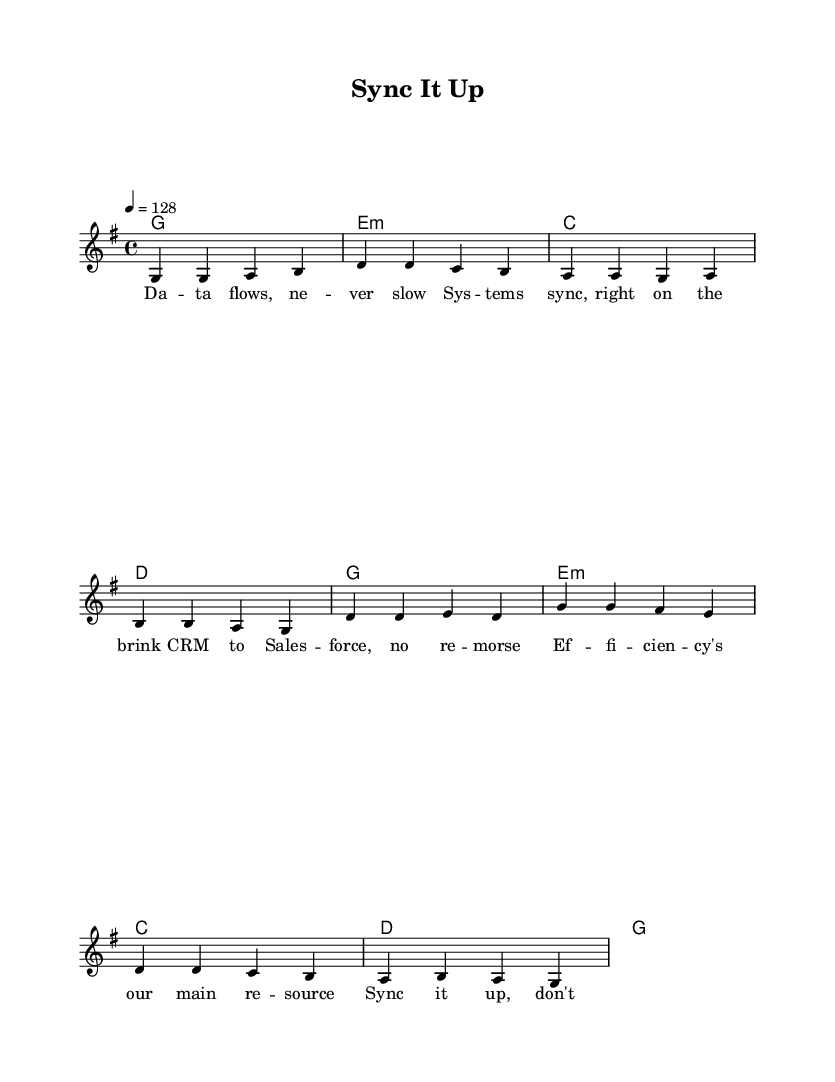What is the key signature of this music? The key signature is G major, which has one sharp (F#). This can be identified by looking at the beginning of the staff where the sharps are notated.
Answer: G major What is the time signature of this music? The time signature is 4/4, which is indicated at the beginning of the score. This means there are four beats in each measure and the quarter note receives one beat.
Answer: 4/4 What is the tempo marking of this music? The tempo marking is 128 beats per minute, as indicated by the tempo instruction (4 = 128) at the beginning of the score. This specifies the speed of the piece.
Answer: 128 How many measures are in the verse section? The verse section consists of four measures, which can be counted by looking at the melody's written notes and bar lines in that section.
Answer: 4 What type of lyrics are included in this piece? The lyrics are energetic and focus on efficiency and productivity in the workplace. This can be derived from reading the lyrics provided in the verse and chorus, which emphasize themes of data flow and smooth workflow.
Answer: Work efficiency What is the chord pattern for the chorus? The chord pattern for the chorus is a sequence of two chords, which are G and Em. This can be determined by analyzing the harmonic progression written underneath the chorus melody.
Answer: G, Em Which K-Pop characteristic is notable in this track? The notable K-Pop characteristic in this track is the dual focus on catchy melodies and motivational lyrics. This can be identified by the vibrant rhythm and surface-level attention to themes that are framed within energetic song structures typical of the genre.
Answer: Catchy melody and motivational lyrics 